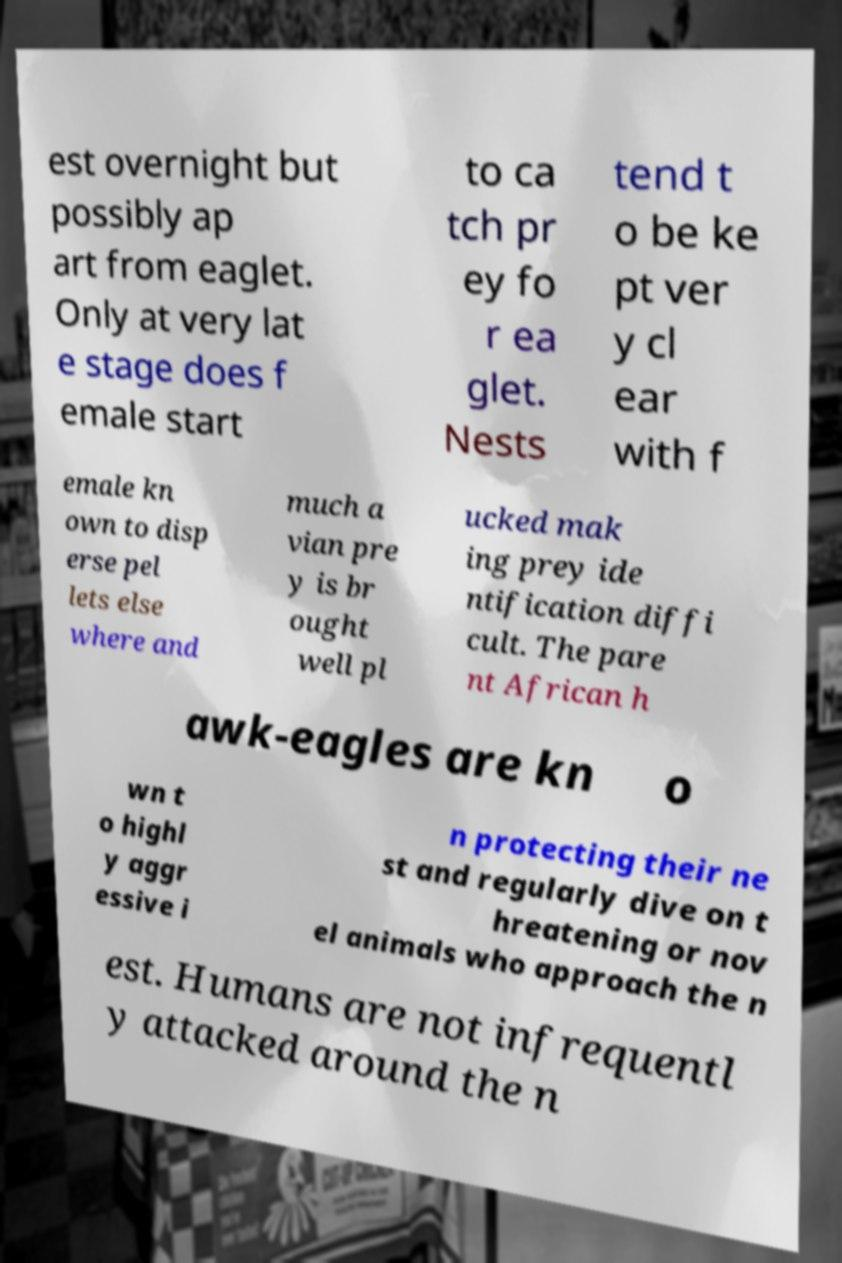I need the written content from this picture converted into text. Can you do that? est overnight but possibly ap art from eaglet. Only at very lat e stage does f emale start to ca tch pr ey fo r ea glet. Nests tend t o be ke pt ver y cl ear with f emale kn own to disp erse pel lets else where and much a vian pre y is br ought well pl ucked mak ing prey ide ntification diffi cult. The pare nt African h awk-eagles are kn o wn t o highl y aggr essive i n protecting their ne st and regularly dive on t hreatening or nov el animals who approach the n est. Humans are not infrequentl y attacked around the n 